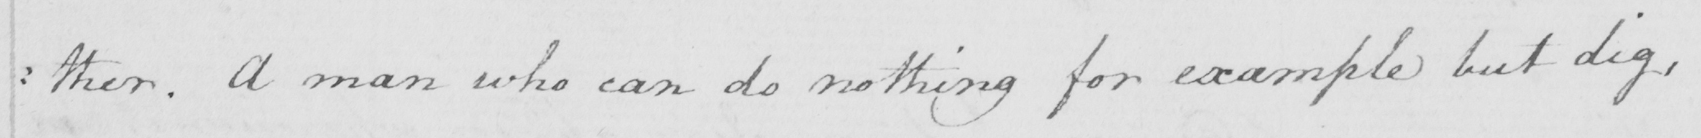Can you tell me what this handwritten text says? : ther . A man who can do nothing for example but dig , 